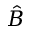Convert formula to latex. <formula><loc_0><loc_0><loc_500><loc_500>\hat { B }</formula> 